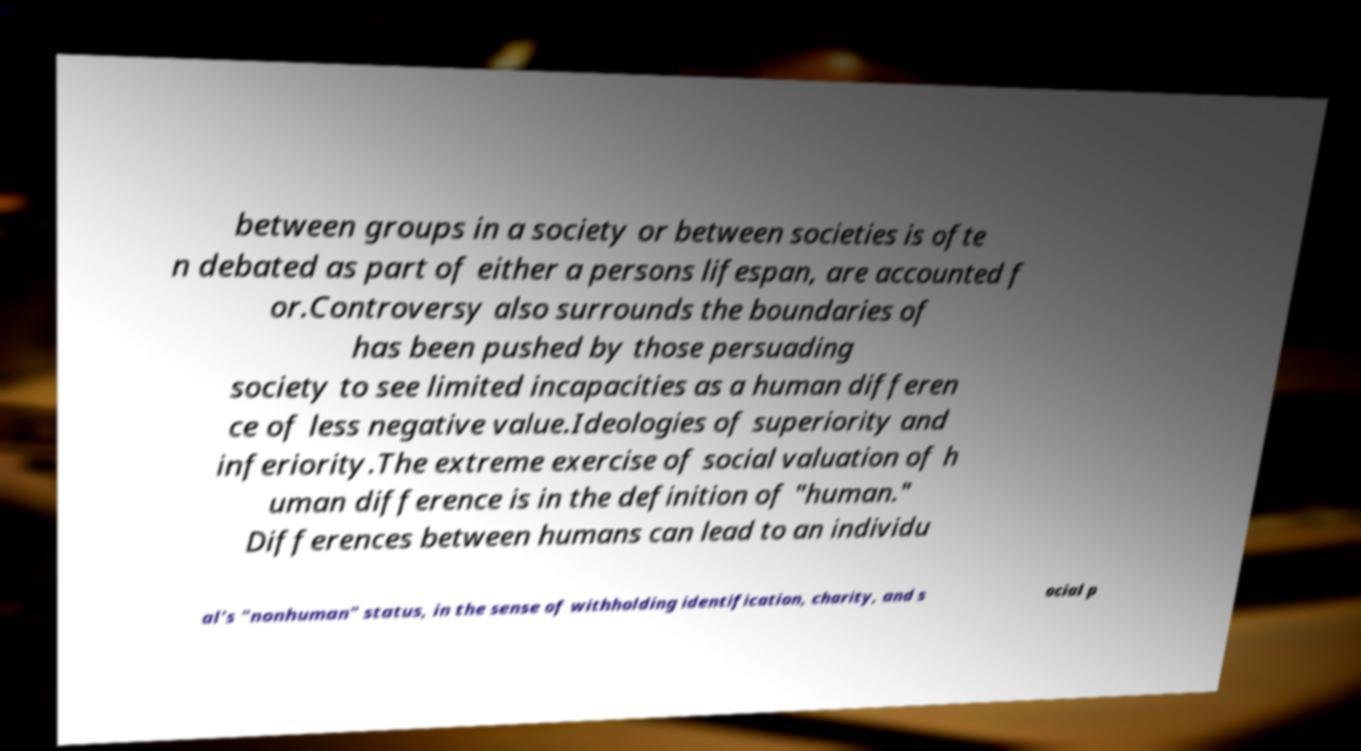What messages or text are displayed in this image? I need them in a readable, typed format. between groups in a society or between societies is ofte n debated as part of either a persons lifespan, are accounted f or.Controversy also surrounds the boundaries of has been pushed by those persuading society to see limited incapacities as a human differen ce of less negative value.Ideologies of superiority and inferiority.The extreme exercise of social valuation of h uman difference is in the definition of "human." Differences between humans can lead to an individu al's "nonhuman" status, in the sense of withholding identification, charity, and s ocial p 